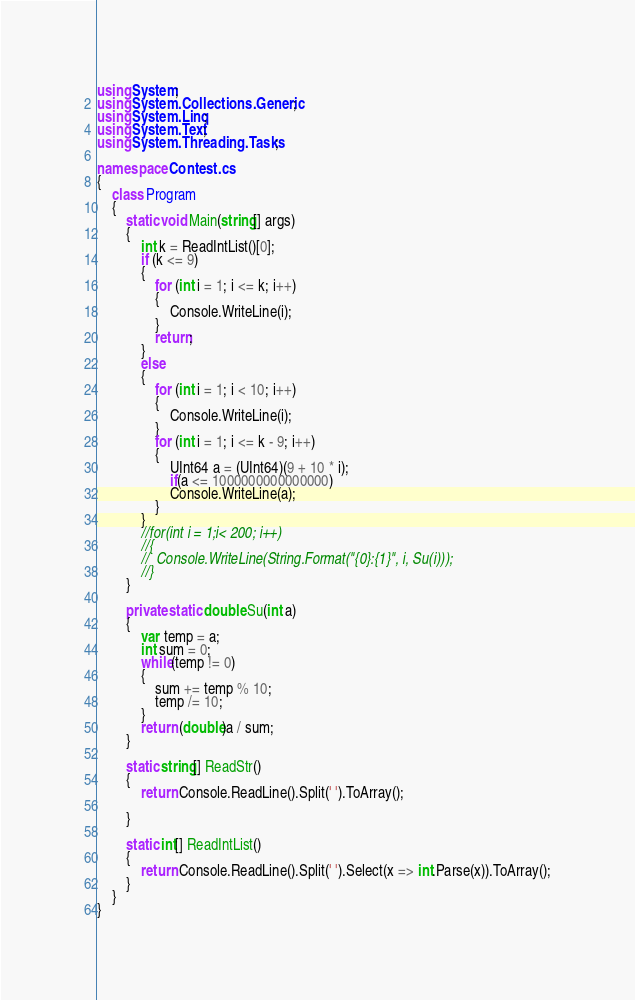Convert code to text. <code><loc_0><loc_0><loc_500><loc_500><_C#_>using System;
using System.Collections.Generic;
using System.Linq;
using System.Text;
using System.Threading.Tasks;

namespace Contest.cs
{
	class Program
	{
		static void Main(string[] args)
		{
			int k = ReadIntList()[0];
			if (k <= 9)
			{
				for (int i = 1; i <= k; i++)
				{
					Console.WriteLine(i);
				}
				return;
			}
			else
			{
				for (int i = 1; i < 10; i++)
				{
					Console.WriteLine(i);
				}
				for (int i = 1; i <= k - 9; i++)
				{
					UInt64 a = (UInt64)(9 + 10 * i);
					if(a <= 1000000000000000)
					Console.WriteLine(a);
				}
			}
			//for(int i = 1;i< 200; i++)
			//{
			//	Console.WriteLine(String.Format("{0}:{1}", i, Su(i)));
			//}
		}

		private static double Su(int a)
		{
			var temp = a;
			int sum = 0;
			while(temp != 0)
			{
				sum += temp % 10;
				temp /= 10;
			}
			return (double)a / sum;
		}

		static string[] ReadStr()
		{
			return Console.ReadLine().Split(' ').ToArray();

		}

		static int[] ReadIntList()
		{
			return Console.ReadLine().Split(' ').Select(x => int.Parse(x)).ToArray();
		}
	}
}</code> 